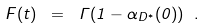Convert formula to latex. <formula><loc_0><loc_0><loc_500><loc_500>F ( t ) \ = \ \Gamma ( 1 - \alpha _ { D ^ { * } } ( 0 ) ) \ .</formula> 